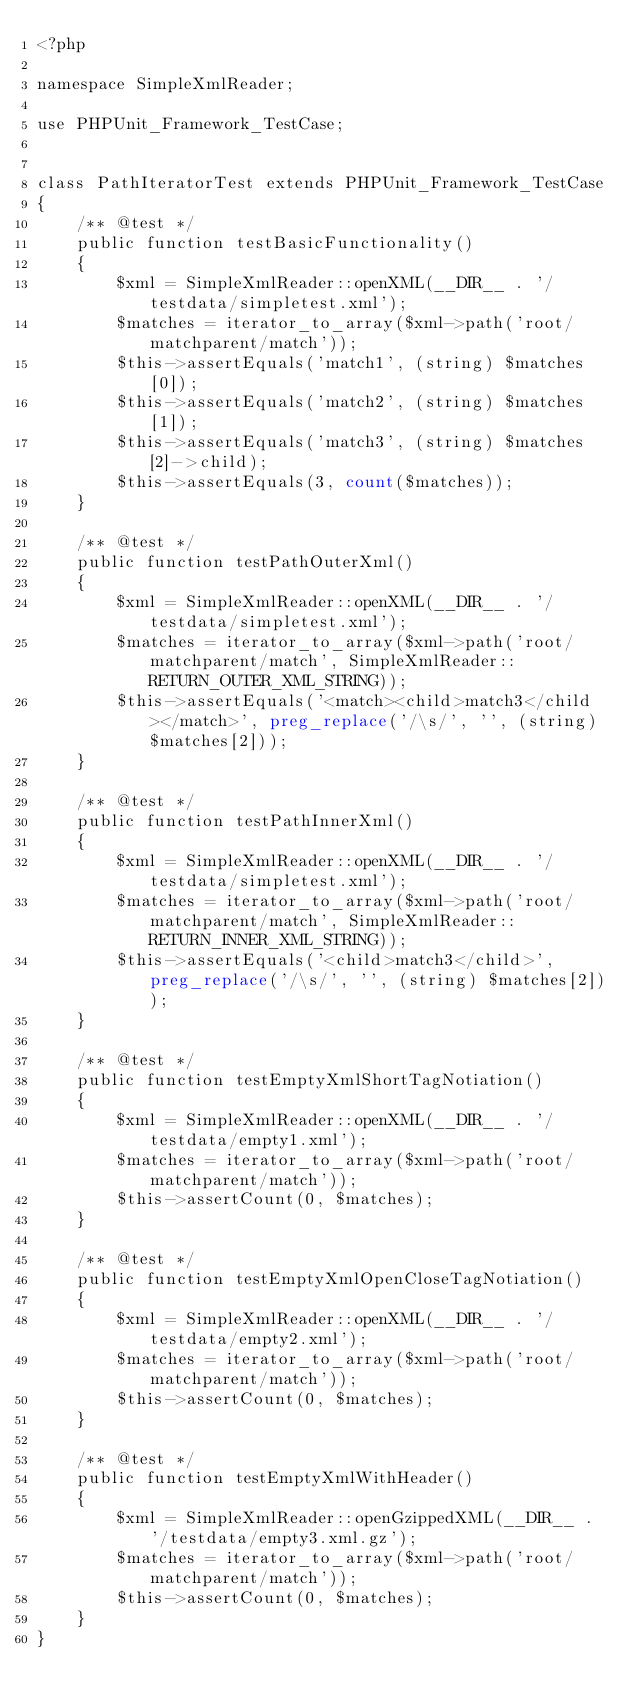Convert code to text. <code><loc_0><loc_0><loc_500><loc_500><_PHP_><?php

namespace SimpleXmlReader;

use PHPUnit_Framework_TestCase;


class PathIteratorTest extends PHPUnit_Framework_TestCase
{
	/** @test */
	public function testBasicFunctionality()
	{
		$xml = SimpleXmlReader::openXML(__DIR__ . '/testdata/simpletest.xml');
		$matches = iterator_to_array($xml->path('root/matchparent/match'));
		$this->assertEquals('match1', (string) $matches[0]);
		$this->assertEquals('match2', (string) $matches[1]);
		$this->assertEquals('match3', (string) $matches[2]->child);
		$this->assertEquals(3, count($matches));
	}

	/** @test */
	public function testPathOuterXml()
	{
		$xml = SimpleXmlReader::openXML(__DIR__ . '/testdata/simpletest.xml');
		$matches = iterator_to_array($xml->path('root/matchparent/match', SimpleXmlReader::RETURN_OUTER_XML_STRING));
		$this->assertEquals('<match><child>match3</child></match>', preg_replace('/\s/', '', (string) $matches[2]));
	}

	/** @test */
	public function testPathInnerXml()
	{
		$xml = SimpleXmlReader::openXML(__DIR__ . '/testdata/simpletest.xml');
		$matches = iterator_to_array($xml->path('root/matchparent/match', SimpleXmlReader::RETURN_INNER_XML_STRING));
		$this->assertEquals('<child>match3</child>', preg_replace('/\s/', '', (string) $matches[2]));
	}

	/** @test */
	public function testEmptyXmlShortTagNotiation()
	{
		$xml = SimpleXmlReader::openXML(__DIR__ . '/testdata/empty1.xml');
		$matches = iterator_to_array($xml->path('root/matchparent/match'));
		$this->assertCount(0, $matches);
	}

	/** @test */
	public function testEmptyXmlOpenCloseTagNotiation()
	{
		$xml = SimpleXmlReader::openXML(__DIR__ . '/testdata/empty2.xml');
		$matches = iterator_to_array($xml->path('root/matchparent/match'));
		$this->assertCount(0, $matches);
	}

	/** @test */
	public function testEmptyXmlWithHeader()
	{
		$xml = SimpleXmlReader::openGzippedXML(__DIR__ . '/testdata/empty3.xml.gz');
		$matches = iterator_to_array($xml->path('root/matchparent/match'));
		$this->assertCount(0, $matches);
	}
}

</code> 